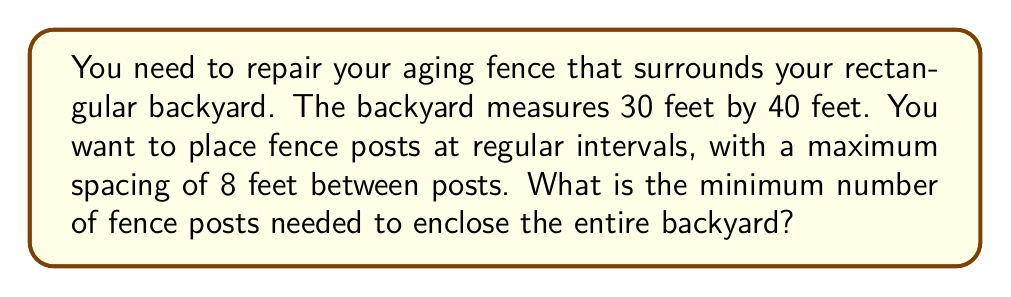Can you answer this question? Let's approach this step-by-step:

1) First, calculate the perimeter of the backyard:
   $$\text{Perimeter} = 2 \times (\text{length} + \text{width}) = 2 \times (30 + 40) = 140 \text{ feet}$$

2) The maximum spacing between posts is 8 feet. To find the number of spaces, divide the perimeter by 8:
   $$\text{Number of spaces} = \frac{\text{Perimeter}}{\text{Max spacing}} = \frac{140}{8} = 17.5$$

3) Since we can't have a fractional number of spaces, we need to round up to the next whole number:
   $$\text{Number of spaces} = \lceil 17.5 \rceil = 18$$

4) The number of posts is always one more than the number of spaces in a closed perimeter:
   $$\text{Number of posts} = \text{Number of spaces} + 1 = 18 + 1 = 19$$

5) Let's verify:
   - 18 spaces of 8 feet each: $18 \times 8 = 144 \text{ feet}$
   - This slightly exceeds our perimeter, which is fine as it ensures we don't exceed the maximum spacing anywhere.

Therefore, the minimum number of fence posts needed is 19.
Answer: 19 fence posts 